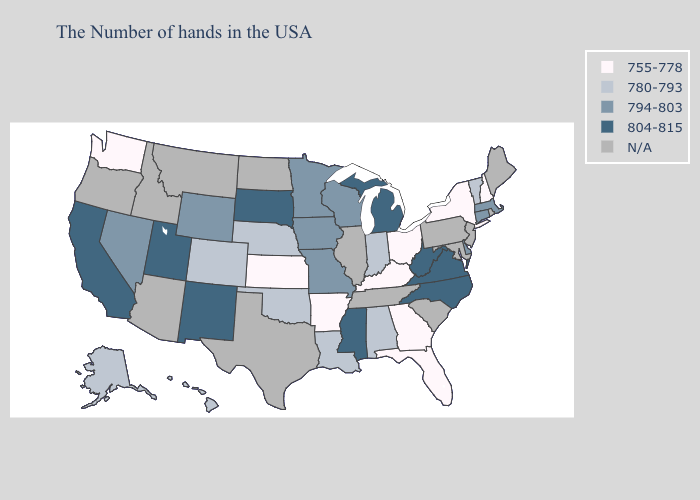Name the states that have a value in the range 794-803?
Be succinct. Massachusetts, Connecticut, Delaware, Wisconsin, Missouri, Minnesota, Iowa, Wyoming, Nevada. What is the highest value in the Northeast ?
Short answer required. 794-803. Among the states that border Nebraska , which have the highest value?
Quick response, please. South Dakota. Name the states that have a value in the range 794-803?
Answer briefly. Massachusetts, Connecticut, Delaware, Wisconsin, Missouri, Minnesota, Iowa, Wyoming, Nevada. Does Michigan have the lowest value in the MidWest?
Quick response, please. No. Which states have the highest value in the USA?
Give a very brief answer. Virginia, North Carolina, West Virginia, Michigan, Mississippi, South Dakota, New Mexico, Utah, California. Name the states that have a value in the range 780-793?
Short answer required. Vermont, Indiana, Alabama, Louisiana, Nebraska, Oklahoma, Colorado, Alaska, Hawaii. Among the states that border Massachusetts , does New Hampshire have the lowest value?
Quick response, please. Yes. Is the legend a continuous bar?
Write a very short answer. No. Does Georgia have the lowest value in the USA?
Quick response, please. Yes. Among the states that border Nevada , which have the lowest value?
Short answer required. Utah, California. What is the value of California?
Quick response, please. 804-815. What is the highest value in states that border Minnesota?
Keep it brief. 804-815. 